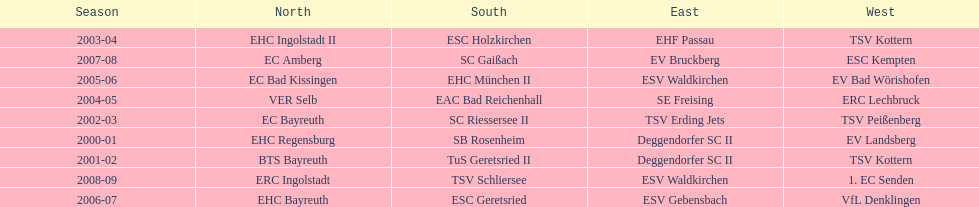What is the number of times deggendorfer sc ii is on the list? 2. 